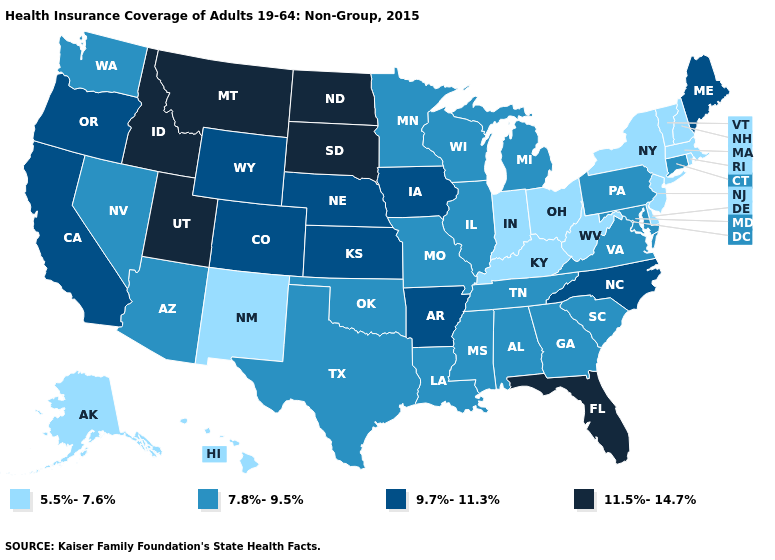Which states have the lowest value in the USA?
Write a very short answer. Alaska, Delaware, Hawaii, Indiana, Kentucky, Massachusetts, New Hampshire, New Jersey, New Mexico, New York, Ohio, Rhode Island, Vermont, West Virginia. What is the value of Massachusetts?
Quick response, please. 5.5%-7.6%. What is the value of Rhode Island?
Write a very short answer. 5.5%-7.6%. Does Maine have the highest value in the Northeast?
Quick response, please. Yes. Does Utah have the highest value in the USA?
Concise answer only. Yes. Among the states that border Maryland , which have the highest value?
Be succinct. Pennsylvania, Virginia. Does New Hampshire have the highest value in the Northeast?
Give a very brief answer. No. Does Florida have the highest value in the South?
Keep it brief. Yes. What is the highest value in the USA?
Write a very short answer. 11.5%-14.7%. Does Florida have the highest value in the South?
Give a very brief answer. Yes. Among the states that border Oregon , does California have the lowest value?
Write a very short answer. No. Does Idaho have a lower value than South Carolina?
Quick response, please. No. Name the states that have a value in the range 9.7%-11.3%?
Keep it brief. Arkansas, California, Colorado, Iowa, Kansas, Maine, Nebraska, North Carolina, Oregon, Wyoming. Name the states that have a value in the range 9.7%-11.3%?
Keep it brief. Arkansas, California, Colorado, Iowa, Kansas, Maine, Nebraska, North Carolina, Oregon, Wyoming. Name the states that have a value in the range 11.5%-14.7%?
Keep it brief. Florida, Idaho, Montana, North Dakota, South Dakota, Utah. 